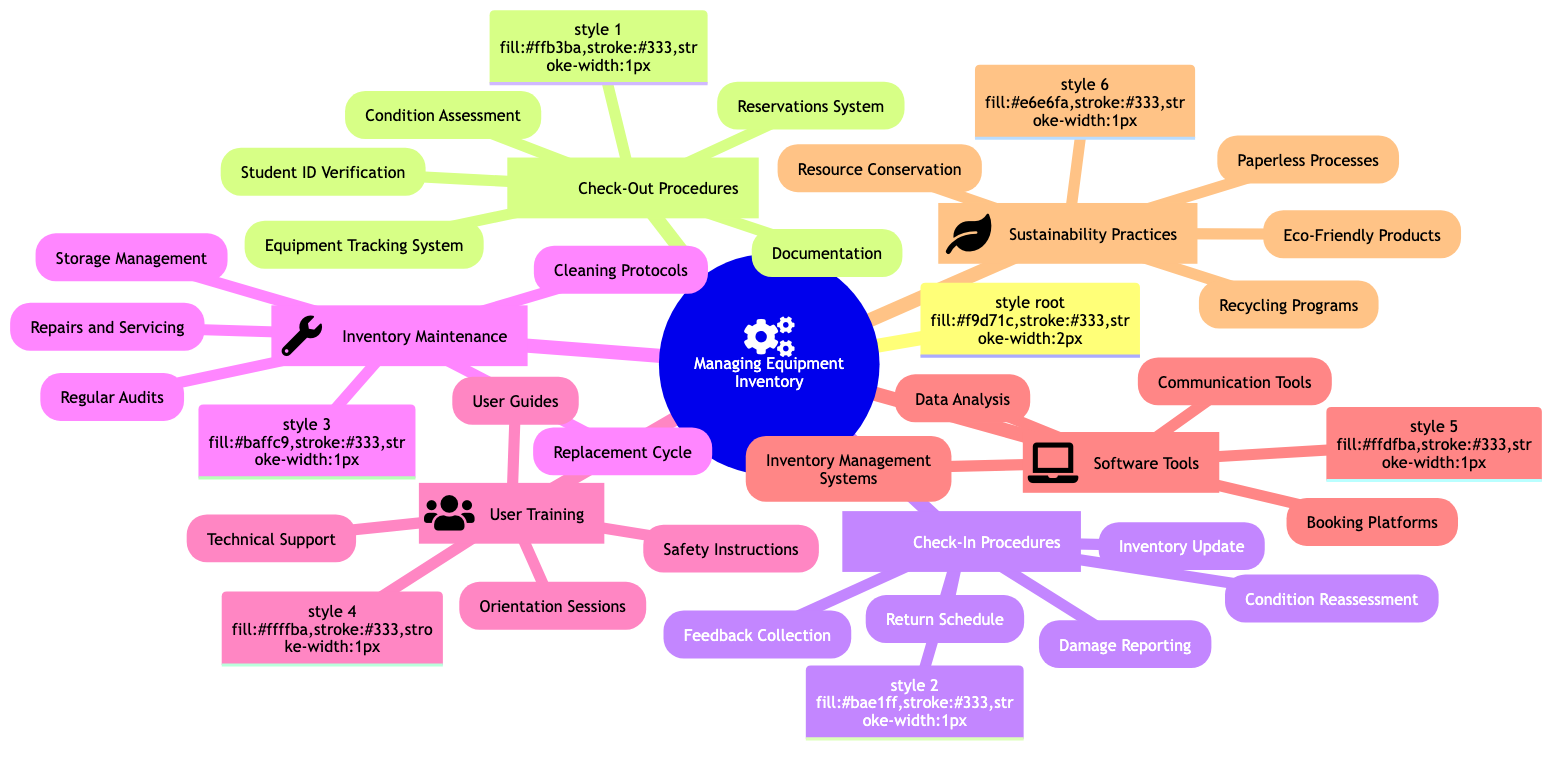what are the procedures listed under Check-Out Procedures? The Check-Out Procedures branch of the diagram lists five procedures: Student ID Verification, Equipment Tracking System, Reservations System, Condition Assessment, and Documentation. I can directly identify these from the nodes under the Check-Out Procedures section.
Answer: Student ID Verification, Equipment Tracking System, Reservations System, Condition Assessment, Documentation how many main categories are there in the diagram? The main categories include Check-Out Procedures, Check-In Procedures, Inventory Maintenance, User Training, Software Tools, and Sustainability Practices. Counting these, there are six categories represented in the diagram.
Answer: 6 what type of system is mentioned for equipment tracking? The diagram specifically mentions an Equipment Tracking System that uses software like Cheqroom. This information is taken directly from the node under the Check-Out Procedures category.
Answer: Cheqroom what is the purpose of Condition Reassessment in Check-In Procedures? The purpose of Condition Reassessment is to conduct a post-return inspection for damages. This is stated specifically under the Check-In Procedures section, which addresses what needs to be done during the equipment return process.
Answer: Post-return inspection for damages which branch discusses sustainability practices? The Sustainability Practices branch is dedicated to eco-friendly approaches within inventory management. This is indicated as a separate category in the diagram, focusing specifically on environmentally sustainable practices.
Answer: Sustainability Practices what is one of the tools mentioned under Software Tools for inventory management? Under the Software Tools section, it mentions Inventory Management Systems, specifically highlighting apps like EZOfficeInventory. This app is listed directly under the related node in the diagram.
Answer: EZOfficeInventory how is equipment cleaning addressed in the diagram? Equipment cleaning is addressed in the Inventory Maintenance section under Cleaning Protocols, which emphasizes sanitizing equipment after each use. This shows a clear guideline for maintaining equipment hygiene in the inventory management process.
Answer: Sanitizing equipment after each use what is the role of Technical Support in User Training? The Technical Support is mentioned as an on-call support for troubleshooting. This role is necessary to aid users who face difficulties or issues with equipment during their rental period, ensuring smooth operations.
Answer: On-call support for troubleshooting which practice encourages users to return equipment promptly? The practice focused on encouraging users to return equipment promptly is referred to as Resource Conservation under the Sustainability Practices section. This shows an effort to maintain efficient inventory usage and sustainability.
Answer: Resource Conservation 